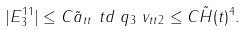Convert formula to latex. <formula><loc_0><loc_0><loc_500><loc_500>| E _ { 3 } ^ { 1 1 } | & \leq C \| \tilde { a } _ { t t } \| _ { \ } t d \| \ q \| _ { 3 } \| \ v _ { t t } \| _ { 2 } \leq C \tilde { H } ( t ) ^ { 4 } .</formula> 